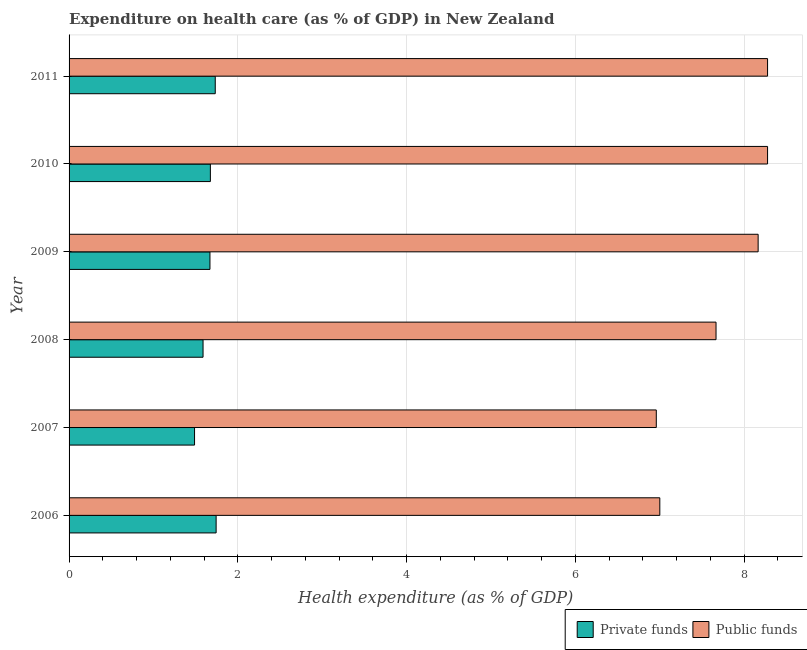Are the number of bars per tick equal to the number of legend labels?
Offer a very short reply. Yes. What is the amount of public funds spent in healthcare in 2008?
Offer a very short reply. 7.67. Across all years, what is the maximum amount of private funds spent in healthcare?
Provide a succinct answer. 1.74. Across all years, what is the minimum amount of private funds spent in healthcare?
Keep it short and to the point. 1.49. In which year was the amount of private funds spent in healthcare minimum?
Give a very brief answer. 2007. What is the total amount of public funds spent in healthcare in the graph?
Give a very brief answer. 46.35. What is the difference between the amount of public funds spent in healthcare in 2006 and that in 2008?
Your answer should be very brief. -0.67. What is the difference between the amount of private funds spent in healthcare in 2010 and the amount of public funds spent in healthcare in 2011?
Ensure brevity in your answer.  -6.6. What is the average amount of public funds spent in healthcare per year?
Your answer should be compact. 7.72. In the year 2011, what is the difference between the amount of public funds spent in healthcare and amount of private funds spent in healthcare?
Ensure brevity in your answer.  6.54. In how many years, is the amount of private funds spent in healthcare greater than 2.8 %?
Offer a very short reply. 0. What is the ratio of the amount of private funds spent in healthcare in 2010 to that in 2011?
Your answer should be very brief. 0.97. Is the amount of private funds spent in healthcare in 2008 less than that in 2009?
Provide a short and direct response. Yes. What is the difference between the highest and the lowest amount of private funds spent in healthcare?
Provide a succinct answer. 0.26. In how many years, is the amount of public funds spent in healthcare greater than the average amount of public funds spent in healthcare taken over all years?
Provide a succinct answer. 3. Is the sum of the amount of private funds spent in healthcare in 2006 and 2010 greater than the maximum amount of public funds spent in healthcare across all years?
Make the answer very short. No. What does the 1st bar from the top in 2006 represents?
Make the answer very short. Public funds. What does the 2nd bar from the bottom in 2008 represents?
Keep it short and to the point. Public funds. How many years are there in the graph?
Your response must be concise. 6. What is the difference between two consecutive major ticks on the X-axis?
Your response must be concise. 2. Does the graph contain grids?
Provide a short and direct response. Yes. How many legend labels are there?
Your answer should be very brief. 2. How are the legend labels stacked?
Provide a short and direct response. Horizontal. What is the title of the graph?
Provide a short and direct response. Expenditure on health care (as % of GDP) in New Zealand. Does "Merchandise imports" appear as one of the legend labels in the graph?
Your response must be concise. No. What is the label or title of the X-axis?
Give a very brief answer. Health expenditure (as % of GDP). What is the Health expenditure (as % of GDP) of Private funds in 2006?
Ensure brevity in your answer.  1.74. What is the Health expenditure (as % of GDP) in Public funds in 2006?
Your answer should be compact. 7. What is the Health expenditure (as % of GDP) of Private funds in 2007?
Provide a succinct answer. 1.49. What is the Health expenditure (as % of GDP) of Public funds in 2007?
Offer a terse response. 6.96. What is the Health expenditure (as % of GDP) in Private funds in 2008?
Offer a terse response. 1.59. What is the Health expenditure (as % of GDP) of Public funds in 2008?
Ensure brevity in your answer.  7.67. What is the Health expenditure (as % of GDP) in Private funds in 2009?
Offer a terse response. 1.67. What is the Health expenditure (as % of GDP) in Public funds in 2009?
Keep it short and to the point. 8.17. What is the Health expenditure (as % of GDP) in Private funds in 2010?
Ensure brevity in your answer.  1.67. What is the Health expenditure (as % of GDP) of Public funds in 2010?
Offer a very short reply. 8.28. What is the Health expenditure (as % of GDP) in Private funds in 2011?
Offer a terse response. 1.73. What is the Health expenditure (as % of GDP) in Public funds in 2011?
Make the answer very short. 8.28. Across all years, what is the maximum Health expenditure (as % of GDP) in Private funds?
Your answer should be very brief. 1.74. Across all years, what is the maximum Health expenditure (as % of GDP) in Public funds?
Your answer should be very brief. 8.28. Across all years, what is the minimum Health expenditure (as % of GDP) of Private funds?
Your answer should be compact. 1.49. Across all years, what is the minimum Health expenditure (as % of GDP) in Public funds?
Ensure brevity in your answer.  6.96. What is the total Health expenditure (as % of GDP) of Private funds in the graph?
Make the answer very short. 9.89. What is the total Health expenditure (as % of GDP) in Public funds in the graph?
Give a very brief answer. 46.35. What is the difference between the Health expenditure (as % of GDP) in Private funds in 2006 and that in 2007?
Keep it short and to the point. 0.26. What is the difference between the Health expenditure (as % of GDP) in Public funds in 2006 and that in 2007?
Your answer should be very brief. 0.04. What is the difference between the Health expenditure (as % of GDP) in Private funds in 2006 and that in 2008?
Your response must be concise. 0.15. What is the difference between the Health expenditure (as % of GDP) of Public funds in 2006 and that in 2008?
Your answer should be very brief. -0.67. What is the difference between the Health expenditure (as % of GDP) of Private funds in 2006 and that in 2009?
Make the answer very short. 0.07. What is the difference between the Health expenditure (as % of GDP) of Public funds in 2006 and that in 2009?
Offer a very short reply. -1.17. What is the difference between the Health expenditure (as % of GDP) of Private funds in 2006 and that in 2010?
Your response must be concise. 0.07. What is the difference between the Health expenditure (as % of GDP) in Public funds in 2006 and that in 2010?
Provide a succinct answer. -1.28. What is the difference between the Health expenditure (as % of GDP) in Private funds in 2006 and that in 2011?
Your answer should be compact. 0.01. What is the difference between the Health expenditure (as % of GDP) of Public funds in 2006 and that in 2011?
Your answer should be compact. -1.28. What is the difference between the Health expenditure (as % of GDP) of Private funds in 2007 and that in 2008?
Offer a terse response. -0.1. What is the difference between the Health expenditure (as % of GDP) in Public funds in 2007 and that in 2008?
Make the answer very short. -0.71. What is the difference between the Health expenditure (as % of GDP) of Private funds in 2007 and that in 2009?
Provide a succinct answer. -0.18. What is the difference between the Health expenditure (as % of GDP) of Public funds in 2007 and that in 2009?
Your answer should be compact. -1.21. What is the difference between the Health expenditure (as % of GDP) of Private funds in 2007 and that in 2010?
Keep it short and to the point. -0.19. What is the difference between the Health expenditure (as % of GDP) of Public funds in 2007 and that in 2010?
Offer a terse response. -1.32. What is the difference between the Health expenditure (as % of GDP) of Private funds in 2007 and that in 2011?
Offer a terse response. -0.25. What is the difference between the Health expenditure (as % of GDP) in Public funds in 2007 and that in 2011?
Your response must be concise. -1.32. What is the difference between the Health expenditure (as % of GDP) in Private funds in 2008 and that in 2009?
Your answer should be compact. -0.08. What is the difference between the Health expenditure (as % of GDP) in Public funds in 2008 and that in 2009?
Your answer should be compact. -0.5. What is the difference between the Health expenditure (as % of GDP) in Private funds in 2008 and that in 2010?
Make the answer very short. -0.09. What is the difference between the Health expenditure (as % of GDP) in Public funds in 2008 and that in 2010?
Your response must be concise. -0.61. What is the difference between the Health expenditure (as % of GDP) of Private funds in 2008 and that in 2011?
Provide a short and direct response. -0.14. What is the difference between the Health expenditure (as % of GDP) in Public funds in 2008 and that in 2011?
Provide a succinct answer. -0.61. What is the difference between the Health expenditure (as % of GDP) of Private funds in 2009 and that in 2010?
Give a very brief answer. -0. What is the difference between the Health expenditure (as % of GDP) in Public funds in 2009 and that in 2010?
Offer a terse response. -0.11. What is the difference between the Health expenditure (as % of GDP) of Private funds in 2009 and that in 2011?
Your response must be concise. -0.06. What is the difference between the Health expenditure (as % of GDP) of Public funds in 2009 and that in 2011?
Your answer should be very brief. -0.11. What is the difference between the Health expenditure (as % of GDP) in Private funds in 2010 and that in 2011?
Provide a short and direct response. -0.06. What is the difference between the Health expenditure (as % of GDP) of Public funds in 2010 and that in 2011?
Your response must be concise. 0. What is the difference between the Health expenditure (as % of GDP) of Private funds in 2006 and the Health expenditure (as % of GDP) of Public funds in 2007?
Your answer should be very brief. -5.22. What is the difference between the Health expenditure (as % of GDP) of Private funds in 2006 and the Health expenditure (as % of GDP) of Public funds in 2008?
Your response must be concise. -5.92. What is the difference between the Health expenditure (as % of GDP) of Private funds in 2006 and the Health expenditure (as % of GDP) of Public funds in 2009?
Ensure brevity in your answer.  -6.42. What is the difference between the Health expenditure (as % of GDP) of Private funds in 2006 and the Health expenditure (as % of GDP) of Public funds in 2010?
Your answer should be compact. -6.53. What is the difference between the Health expenditure (as % of GDP) in Private funds in 2006 and the Health expenditure (as % of GDP) in Public funds in 2011?
Keep it short and to the point. -6.53. What is the difference between the Health expenditure (as % of GDP) of Private funds in 2007 and the Health expenditure (as % of GDP) of Public funds in 2008?
Your response must be concise. -6.18. What is the difference between the Health expenditure (as % of GDP) of Private funds in 2007 and the Health expenditure (as % of GDP) of Public funds in 2009?
Provide a succinct answer. -6.68. What is the difference between the Health expenditure (as % of GDP) of Private funds in 2007 and the Health expenditure (as % of GDP) of Public funds in 2010?
Keep it short and to the point. -6.79. What is the difference between the Health expenditure (as % of GDP) in Private funds in 2007 and the Health expenditure (as % of GDP) in Public funds in 2011?
Provide a succinct answer. -6.79. What is the difference between the Health expenditure (as % of GDP) in Private funds in 2008 and the Health expenditure (as % of GDP) in Public funds in 2009?
Give a very brief answer. -6.58. What is the difference between the Health expenditure (as % of GDP) of Private funds in 2008 and the Health expenditure (as % of GDP) of Public funds in 2010?
Give a very brief answer. -6.69. What is the difference between the Health expenditure (as % of GDP) in Private funds in 2008 and the Health expenditure (as % of GDP) in Public funds in 2011?
Your response must be concise. -6.69. What is the difference between the Health expenditure (as % of GDP) of Private funds in 2009 and the Health expenditure (as % of GDP) of Public funds in 2010?
Provide a succinct answer. -6.61. What is the difference between the Health expenditure (as % of GDP) in Private funds in 2009 and the Health expenditure (as % of GDP) in Public funds in 2011?
Provide a short and direct response. -6.61. What is the difference between the Health expenditure (as % of GDP) of Private funds in 2010 and the Health expenditure (as % of GDP) of Public funds in 2011?
Keep it short and to the point. -6.6. What is the average Health expenditure (as % of GDP) of Private funds per year?
Keep it short and to the point. 1.65. What is the average Health expenditure (as % of GDP) of Public funds per year?
Make the answer very short. 7.72. In the year 2006, what is the difference between the Health expenditure (as % of GDP) of Private funds and Health expenditure (as % of GDP) of Public funds?
Your response must be concise. -5.26. In the year 2007, what is the difference between the Health expenditure (as % of GDP) in Private funds and Health expenditure (as % of GDP) in Public funds?
Provide a short and direct response. -5.47. In the year 2008, what is the difference between the Health expenditure (as % of GDP) of Private funds and Health expenditure (as % of GDP) of Public funds?
Ensure brevity in your answer.  -6.08. In the year 2009, what is the difference between the Health expenditure (as % of GDP) in Private funds and Health expenditure (as % of GDP) in Public funds?
Your answer should be very brief. -6.5. In the year 2010, what is the difference between the Health expenditure (as % of GDP) in Private funds and Health expenditure (as % of GDP) in Public funds?
Provide a succinct answer. -6.6. In the year 2011, what is the difference between the Health expenditure (as % of GDP) of Private funds and Health expenditure (as % of GDP) of Public funds?
Provide a short and direct response. -6.55. What is the ratio of the Health expenditure (as % of GDP) in Private funds in 2006 to that in 2007?
Provide a succinct answer. 1.17. What is the ratio of the Health expenditure (as % of GDP) of Private funds in 2006 to that in 2008?
Provide a succinct answer. 1.1. What is the ratio of the Health expenditure (as % of GDP) of Public funds in 2006 to that in 2008?
Your answer should be compact. 0.91. What is the ratio of the Health expenditure (as % of GDP) in Private funds in 2006 to that in 2009?
Make the answer very short. 1.04. What is the ratio of the Health expenditure (as % of GDP) in Public funds in 2006 to that in 2009?
Provide a short and direct response. 0.86. What is the ratio of the Health expenditure (as % of GDP) in Private funds in 2006 to that in 2010?
Offer a terse response. 1.04. What is the ratio of the Health expenditure (as % of GDP) of Public funds in 2006 to that in 2010?
Offer a very short reply. 0.85. What is the ratio of the Health expenditure (as % of GDP) of Private funds in 2006 to that in 2011?
Provide a succinct answer. 1.01. What is the ratio of the Health expenditure (as % of GDP) of Public funds in 2006 to that in 2011?
Keep it short and to the point. 0.85. What is the ratio of the Health expenditure (as % of GDP) in Private funds in 2007 to that in 2008?
Offer a very short reply. 0.94. What is the ratio of the Health expenditure (as % of GDP) of Public funds in 2007 to that in 2008?
Your response must be concise. 0.91. What is the ratio of the Health expenditure (as % of GDP) in Private funds in 2007 to that in 2009?
Make the answer very short. 0.89. What is the ratio of the Health expenditure (as % of GDP) of Public funds in 2007 to that in 2009?
Your answer should be very brief. 0.85. What is the ratio of the Health expenditure (as % of GDP) of Private funds in 2007 to that in 2010?
Your answer should be very brief. 0.89. What is the ratio of the Health expenditure (as % of GDP) of Public funds in 2007 to that in 2010?
Provide a succinct answer. 0.84. What is the ratio of the Health expenditure (as % of GDP) in Private funds in 2007 to that in 2011?
Keep it short and to the point. 0.86. What is the ratio of the Health expenditure (as % of GDP) in Public funds in 2007 to that in 2011?
Your answer should be compact. 0.84. What is the ratio of the Health expenditure (as % of GDP) in Private funds in 2008 to that in 2009?
Offer a terse response. 0.95. What is the ratio of the Health expenditure (as % of GDP) in Public funds in 2008 to that in 2009?
Your answer should be compact. 0.94. What is the ratio of the Health expenditure (as % of GDP) in Private funds in 2008 to that in 2010?
Give a very brief answer. 0.95. What is the ratio of the Health expenditure (as % of GDP) in Public funds in 2008 to that in 2010?
Give a very brief answer. 0.93. What is the ratio of the Health expenditure (as % of GDP) in Private funds in 2008 to that in 2011?
Provide a short and direct response. 0.92. What is the ratio of the Health expenditure (as % of GDP) of Public funds in 2008 to that in 2011?
Provide a short and direct response. 0.93. What is the ratio of the Health expenditure (as % of GDP) of Private funds in 2009 to that in 2010?
Ensure brevity in your answer.  1. What is the ratio of the Health expenditure (as % of GDP) of Public funds in 2009 to that in 2010?
Provide a short and direct response. 0.99. What is the ratio of the Health expenditure (as % of GDP) in Private funds in 2009 to that in 2011?
Give a very brief answer. 0.96. What is the ratio of the Health expenditure (as % of GDP) in Public funds in 2009 to that in 2011?
Provide a short and direct response. 0.99. What is the ratio of the Health expenditure (as % of GDP) of Private funds in 2010 to that in 2011?
Keep it short and to the point. 0.97. What is the ratio of the Health expenditure (as % of GDP) in Public funds in 2010 to that in 2011?
Your response must be concise. 1. What is the difference between the highest and the second highest Health expenditure (as % of GDP) in Private funds?
Ensure brevity in your answer.  0.01. What is the difference between the highest and the lowest Health expenditure (as % of GDP) in Private funds?
Offer a very short reply. 0.26. What is the difference between the highest and the lowest Health expenditure (as % of GDP) in Public funds?
Your response must be concise. 1.32. 